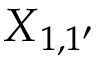Convert formula to latex. <formula><loc_0><loc_0><loc_500><loc_500>X { _ { 1 , 1 ^ { \prime } } }</formula> 